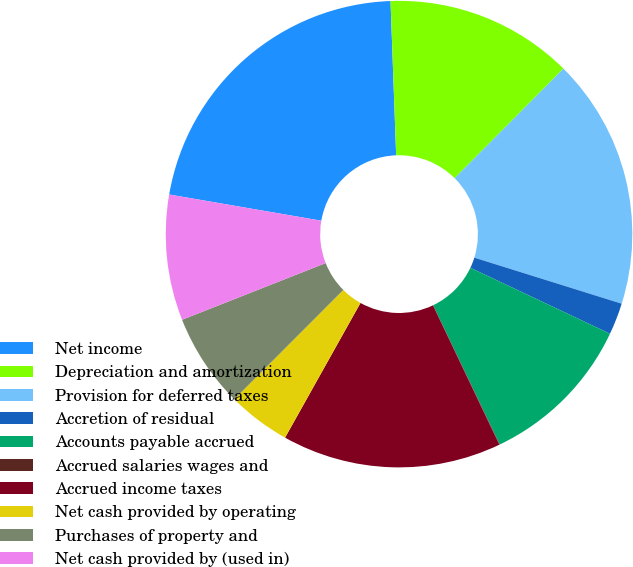Convert chart. <chart><loc_0><loc_0><loc_500><loc_500><pie_chart><fcel>Net income<fcel>Depreciation and amortization<fcel>Provision for deferred taxes<fcel>Accretion of residual<fcel>Accounts payable accrued<fcel>Accrued salaries wages and<fcel>Accrued income taxes<fcel>Net cash provided by operating<fcel>Purchases of property and<fcel>Net cash provided by (used in)<nl><fcel>21.7%<fcel>13.03%<fcel>17.37%<fcel>2.2%<fcel>10.87%<fcel>0.03%<fcel>15.2%<fcel>4.36%<fcel>6.53%<fcel>8.7%<nl></chart> 